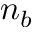Convert formula to latex. <formula><loc_0><loc_0><loc_500><loc_500>n _ { b }</formula> 